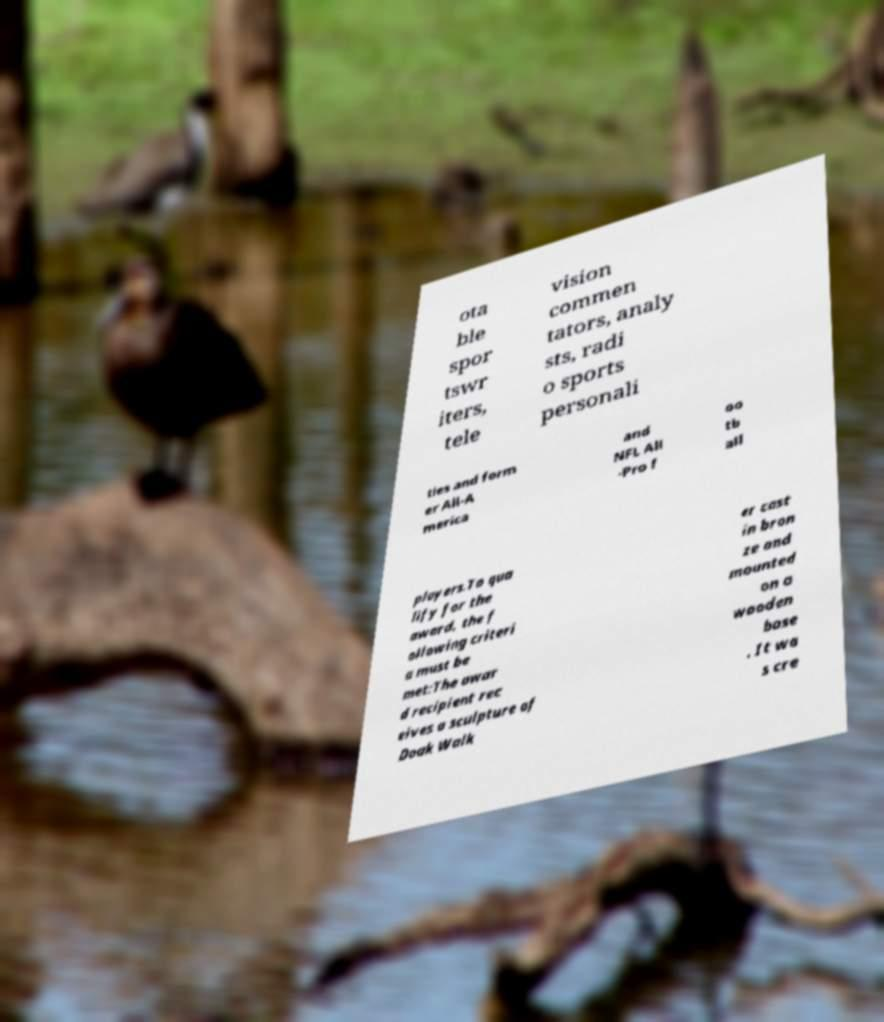Please read and relay the text visible in this image. What does it say? ota ble spor tswr iters, tele vision commen tators, analy sts, radi o sports personali ties and form er All-A merica and NFL All -Pro f oo tb all players.To qua lify for the award, the f ollowing criteri a must be met:The awar d recipient rec eives a sculpture of Doak Walk er cast in bron ze and mounted on a wooden base . It wa s cre 